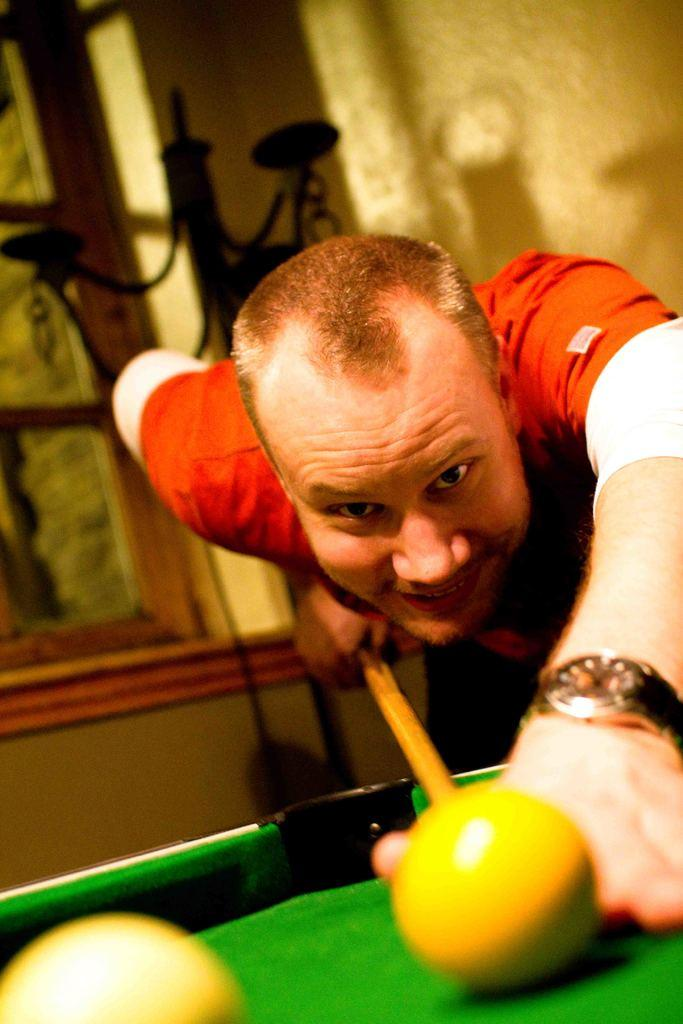What is the position of the man in the room? The man is standing bent in the room. What is the man holding in the image? The man is holding a stick in the image. What is the purpose of the stick in the image? The stick is used to hit snooker balls in the image. What can be seen in the room besides the man and the stick? There is a window in the room. What type of farm animals can be seen in the image? There are no farm animals present in the image; it features a man standing bent and holding a stick used for snooker. 